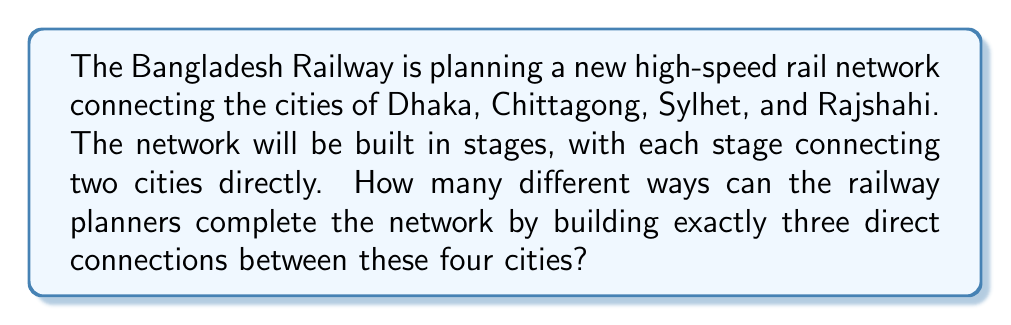Solve this math problem. Let's approach this step-by-step using combinatorics:

1) First, we need to determine how many possible direct connections there are between four cities. This is equivalent to choosing 2 cities from 4, which can be calculated using the combination formula:

   $$\binom{4}{2} = \frac{4!}{2!(4-2)!} = \frac{4 \cdot 3}{2 \cdot 1} = 6$$

   So there are 6 possible direct connections in total.

2) Now, we need to choose 3 of these 6 possible connections. This can again be calculated using the combination formula:

   $$\binom{6}{3} = \frac{6!}{3!(6-3)!} = \frac{6 \cdot 5 \cdot 4}{3 \cdot 2 \cdot 1} = 20$$

3) However, we need to ensure that our chosen connections form a connected network. Not all combinations of 3 connections will do this. We need to exclude the cases where we choose 3 connections that leave one city isolated.

4) There are $\binom{4}{1} = 4$ ways to choose a city to isolate, and for each of these, there are $\binom{3}{2} = 3$ ways to connect the remaining three cities.

5) Therefore, the number of invalid combinations is:

   $$4 \cdot 3 = 12$$

6) So, the final number of valid ways to complete the network is:

   $$20 - 12 = 8$$

Thus, there are 8 different ways the railway planners can complete the network by building exactly three direct connections between the four cities.
Answer: 8 ways 